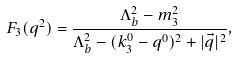Convert formula to latex. <formula><loc_0><loc_0><loc_500><loc_500>F _ { 3 } ( q ^ { 2 } ) = \frac { \Lambda _ { b } ^ { 2 } - m _ { 3 } ^ { 2 } } { \Lambda _ { b } ^ { 2 } - ( k _ { 3 } ^ { 0 } - q ^ { 0 } ) ^ { 2 } + | \vec { q } | ^ { 2 } } ,</formula> 